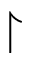Convert formula to latex. <formula><loc_0><loc_0><loc_500><loc_500>\upharpoonright</formula> 